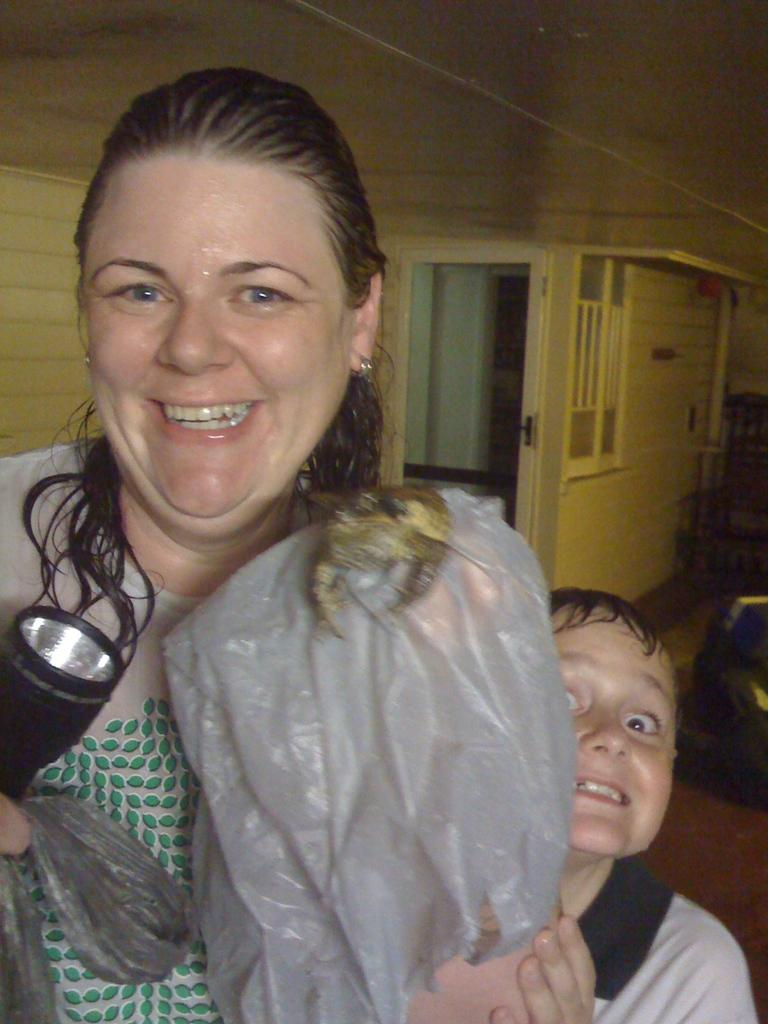Who is present in the image? There is a kid and a woman in the image. What is the woman holding in the image? The woman is holding a torch. What is the expression on the faces of the kid and the woman? The kid and the woman are looking and smiling at someone. What type of zephyr can be seen in the image? There is no zephyr present in the image. What kind of trouble is the woman causing in the image? There is no indication of trouble or any negative actions in the image. 